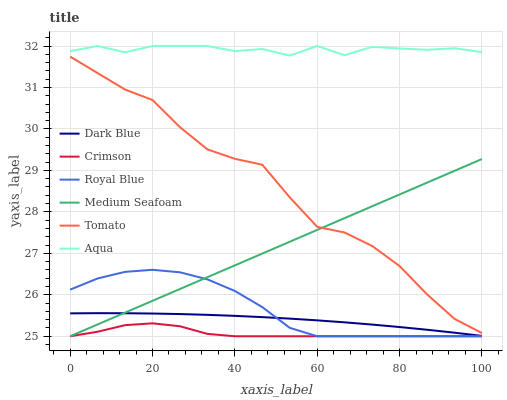Does Crimson have the minimum area under the curve?
Answer yes or no. Yes. Does Aqua have the maximum area under the curve?
Answer yes or no. Yes. Does Royal Blue have the minimum area under the curve?
Answer yes or no. No. Does Royal Blue have the maximum area under the curve?
Answer yes or no. No. Is Medium Seafoam the smoothest?
Answer yes or no. Yes. Is Tomato the roughest?
Answer yes or no. Yes. Is Royal Blue the smoothest?
Answer yes or no. No. Is Royal Blue the roughest?
Answer yes or no. No. Does Royal Blue have the lowest value?
Answer yes or no. Yes. Does Aqua have the lowest value?
Answer yes or no. No. Does Aqua have the highest value?
Answer yes or no. Yes. Does Royal Blue have the highest value?
Answer yes or no. No. Is Royal Blue less than Aqua?
Answer yes or no. Yes. Is Aqua greater than Dark Blue?
Answer yes or no. Yes. Does Royal Blue intersect Dark Blue?
Answer yes or no. Yes. Is Royal Blue less than Dark Blue?
Answer yes or no. No. Is Royal Blue greater than Dark Blue?
Answer yes or no. No. Does Royal Blue intersect Aqua?
Answer yes or no. No. 